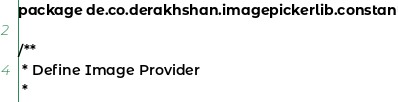<code> <loc_0><loc_0><loc_500><loc_500><_Kotlin_>package de.co.derakhshan.imagepickerlib.constant

/**
 * Define Image Provider
 *</code> 